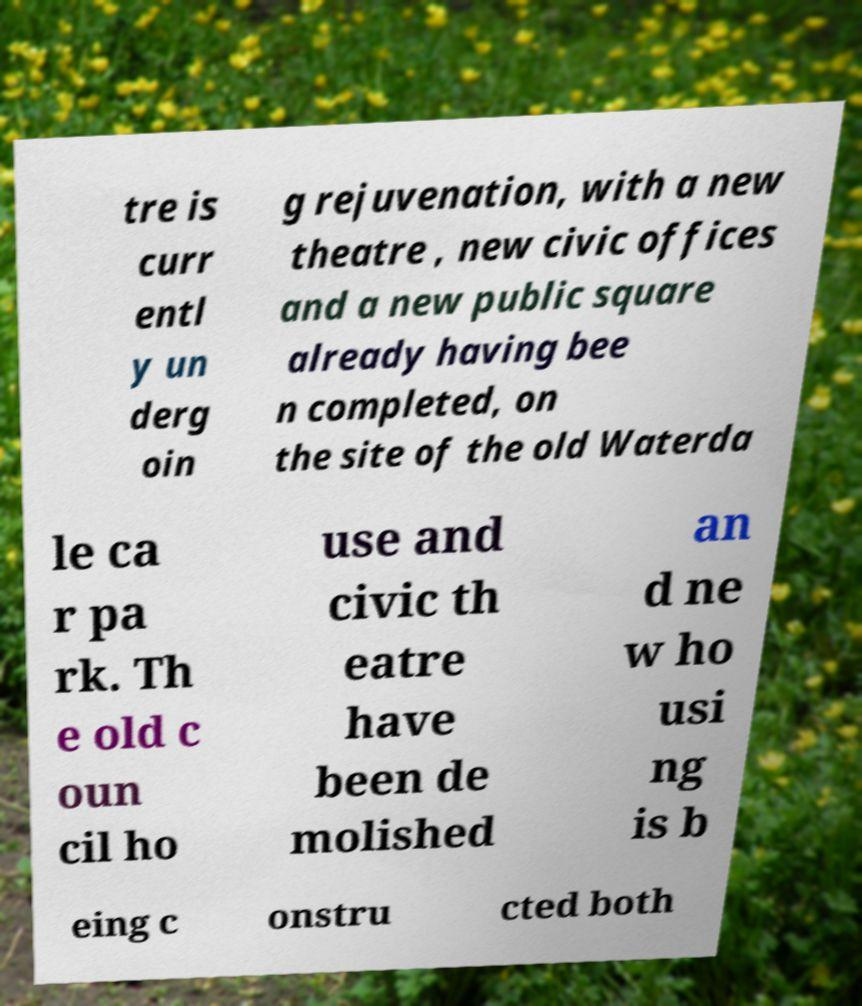Please identify and transcribe the text found in this image. tre is curr entl y un derg oin g rejuvenation, with a new theatre , new civic offices and a new public square already having bee n completed, on the site of the old Waterda le ca r pa rk. Th e old c oun cil ho use and civic th eatre have been de molished an d ne w ho usi ng is b eing c onstru cted both 